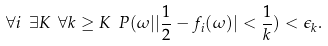Convert formula to latex. <formula><loc_0><loc_0><loc_500><loc_500>\forall i \ \exists K \ \forall k \geq K \ P ( \omega | | \frac { 1 } { 2 } - f _ { i } ( \omega ) | < \frac { 1 } { k } ) < \epsilon _ { k } .</formula> 